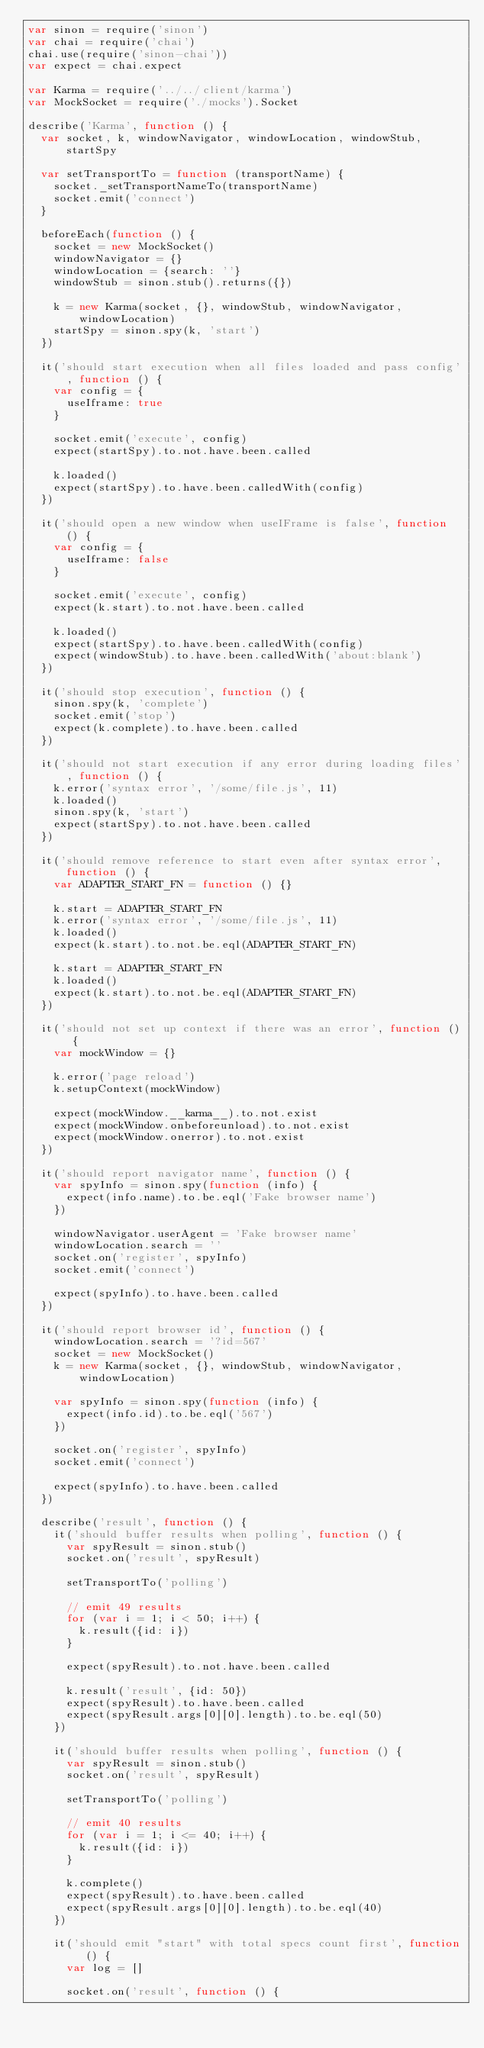<code> <loc_0><loc_0><loc_500><loc_500><_JavaScript_>var sinon = require('sinon')
var chai = require('chai')
chai.use(require('sinon-chai'))
var expect = chai.expect

var Karma = require('../../client/karma')
var MockSocket = require('./mocks').Socket

describe('Karma', function () {
  var socket, k, windowNavigator, windowLocation, windowStub, startSpy

  var setTransportTo = function (transportName) {
    socket._setTransportNameTo(transportName)
    socket.emit('connect')
  }

  beforeEach(function () {
    socket = new MockSocket()
    windowNavigator = {}
    windowLocation = {search: ''}
    windowStub = sinon.stub().returns({})

    k = new Karma(socket, {}, windowStub, windowNavigator, windowLocation)
    startSpy = sinon.spy(k, 'start')
  })

  it('should start execution when all files loaded and pass config', function () {
    var config = {
      useIframe: true
    }

    socket.emit('execute', config)
    expect(startSpy).to.not.have.been.called

    k.loaded()
    expect(startSpy).to.have.been.calledWith(config)
  })

  it('should open a new window when useIFrame is false', function () {
    var config = {
      useIframe: false
    }

    socket.emit('execute', config)
    expect(k.start).to.not.have.been.called

    k.loaded()
    expect(startSpy).to.have.been.calledWith(config)
    expect(windowStub).to.have.been.calledWith('about:blank')
  })

  it('should stop execution', function () {
    sinon.spy(k, 'complete')
    socket.emit('stop')
    expect(k.complete).to.have.been.called
  })

  it('should not start execution if any error during loading files', function () {
    k.error('syntax error', '/some/file.js', 11)
    k.loaded()
    sinon.spy(k, 'start')
    expect(startSpy).to.not.have.been.called
  })

  it('should remove reference to start even after syntax error', function () {
    var ADAPTER_START_FN = function () {}

    k.start = ADAPTER_START_FN
    k.error('syntax error', '/some/file.js', 11)
    k.loaded()
    expect(k.start).to.not.be.eql(ADAPTER_START_FN)

    k.start = ADAPTER_START_FN
    k.loaded()
    expect(k.start).to.not.be.eql(ADAPTER_START_FN)
  })

  it('should not set up context if there was an error', function () {
    var mockWindow = {}

    k.error('page reload')
    k.setupContext(mockWindow)

    expect(mockWindow.__karma__).to.not.exist
    expect(mockWindow.onbeforeunload).to.not.exist
    expect(mockWindow.onerror).to.not.exist
  })

  it('should report navigator name', function () {
    var spyInfo = sinon.spy(function (info) {
      expect(info.name).to.be.eql('Fake browser name')
    })

    windowNavigator.userAgent = 'Fake browser name'
    windowLocation.search = ''
    socket.on('register', spyInfo)
    socket.emit('connect')

    expect(spyInfo).to.have.been.called
  })

  it('should report browser id', function () {
    windowLocation.search = '?id=567'
    socket = new MockSocket()
    k = new Karma(socket, {}, windowStub, windowNavigator, windowLocation)

    var spyInfo = sinon.spy(function (info) {
      expect(info.id).to.be.eql('567')
    })

    socket.on('register', spyInfo)
    socket.emit('connect')

    expect(spyInfo).to.have.been.called
  })

  describe('result', function () {
    it('should buffer results when polling', function () {
      var spyResult = sinon.stub()
      socket.on('result', spyResult)

      setTransportTo('polling')

      // emit 49 results
      for (var i = 1; i < 50; i++) {
        k.result({id: i})
      }

      expect(spyResult).to.not.have.been.called

      k.result('result', {id: 50})
      expect(spyResult).to.have.been.called
      expect(spyResult.args[0][0].length).to.be.eql(50)
    })

    it('should buffer results when polling', function () {
      var spyResult = sinon.stub()
      socket.on('result', spyResult)

      setTransportTo('polling')

      // emit 40 results
      for (var i = 1; i <= 40; i++) {
        k.result({id: i})
      }

      k.complete()
      expect(spyResult).to.have.been.called
      expect(spyResult.args[0][0].length).to.be.eql(40)
    })

    it('should emit "start" with total specs count first', function () {
      var log = []

      socket.on('result', function () {</code> 